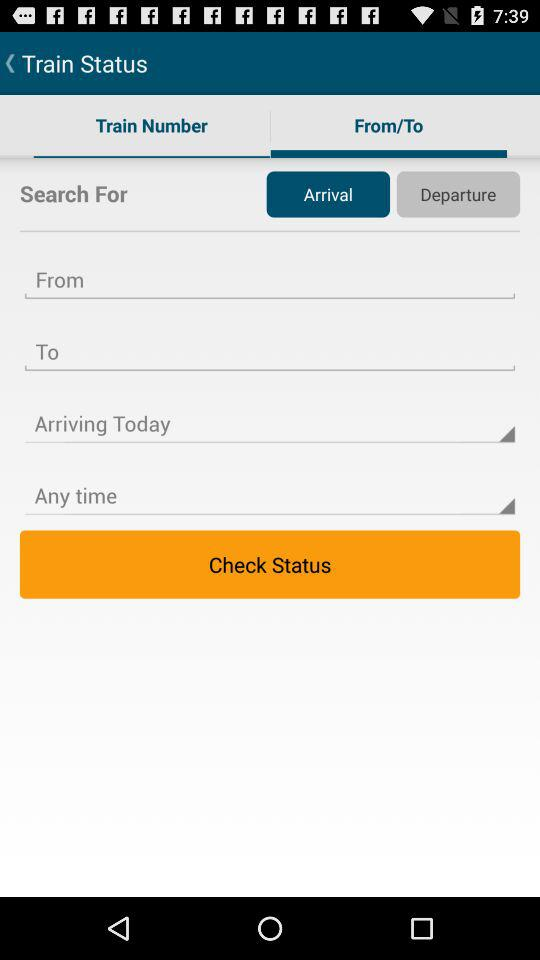Which tab has been selected? The tab that has been selected is From/To. 